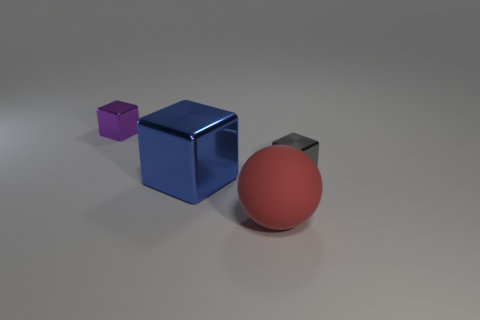Add 1 tiny metallic cubes. How many objects exist? 5 Subtract all blocks. How many objects are left? 1 Subtract 0 purple balls. How many objects are left? 4 Subtract all blue metallic things. Subtract all small gray metal things. How many objects are left? 2 Add 4 large red matte objects. How many large red matte objects are left? 5 Add 3 blocks. How many blocks exist? 6 